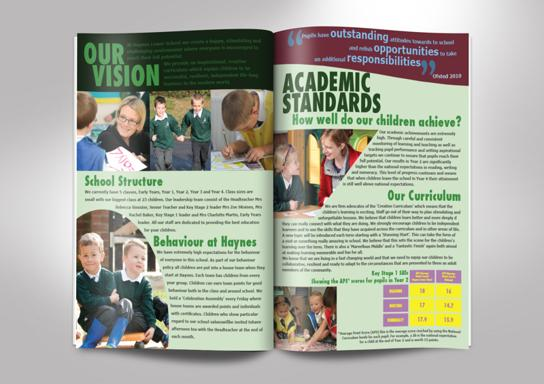Can you describe the behavior guidelines or policies shown in the 'Behaviour at Haynes' section? The 'Behaviour at Haynes' section in the image discusses the expected conduct of students, emphasizing respect, integrity, and discipline. The guidelines likely include components of behavioral expectations inside and outside the classroom, strategies on conflict resolution, and respect for community and school property. How is this information visually presented in the magazine? The behavior policies are outlined using clean, bullet-point formatting to make the rules clear and straightforward. There might be engaging visuals or icons next to each rule to visually represent the behaviors, making them easily understandable for all age groups. 